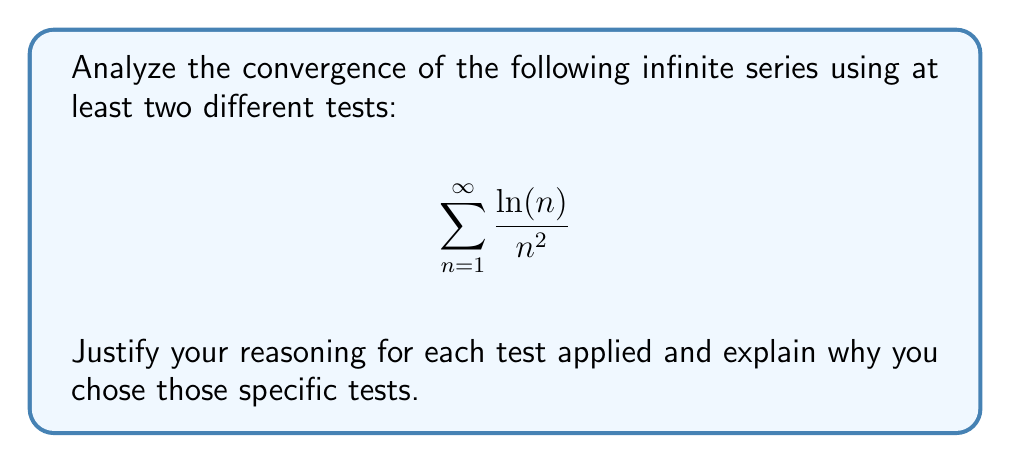Solve this math problem. Let's analyze the convergence of this series using multiple tests:

1. Comparison Test:

We can compare this series to a known convergent p-series. For $n \geq 3$, we have:

$$\frac{\ln(n)}{n^2} < \frac{n}{n^2} = \frac{1}{n}$$

Since $\sum_{n=1}^{\infty} \frac{1}{n}$ diverges (harmonic series), this comparison is not helpful. Let's try a tighter bound:

For $n \geq 3$, $\ln(n) < \sqrt{n}$. Therefore:

$$\frac{\ln(n)}{n^2} < \frac{\sqrt{n}}{n^2} = \frac{1}{n^{3/2}}$$

We know that $\sum_{n=1}^{\infty} \frac{1}{n^{3/2}}$ converges (p-series with $p > 1$). By the comparison test, our original series also converges.

2. Limit Comparison Test:

Let's compare our series to $\sum_{n=1}^{\infty} \frac{1}{n^{3/2}}$:

$$\lim_{n \to \infty} \frac{\frac{\ln(n)}{n^2}}{\frac{1}{n^{3/2}}} = \lim_{n \to \infty} \frac{\ln(n)}{n^{1/2}} = 0$$

Since this limit exists and is finite, both series have the same convergence behavior. As we know $\sum_{n=1}^{\infty} \frac{1}{n^{3/2}}$ converges, our original series also converges.

3. Ratio Test:

Let $a_n = \frac{\ln(n)}{n^2}$. Then:

$$\begin{align*}
\lim_{n \to \infty} \left|\frac{a_{n+1}}{a_n}\right| &= \lim_{n \to \infty} \left|\frac{\ln(n+1)}{(n+1)^2} \cdot \frac{n^2}{\ln(n)}\right| \\
&= \lim_{n \to \infty} \left(\frac{n}{n+1}\right)^2 \cdot \frac{\ln(n+1)}{\ln(n)} \\
&= 1 \cdot 1 = 1
\end{align*}$$

Since the limit equals 1, the ratio test is inconclusive.

We chose these tests because:
1. The comparison test is often useful for series involving logarithms and powers.
2. The limit comparison test can be more precise when direct comparison is difficult.
3. The ratio test is generally applicable and can sometimes provide conclusive results quickly.
Answer: The series $\sum_{n=1}^{\infty} \frac{\ln(n)}{n^2}$ converges. This is proven by both the comparison test and the limit comparison test, while the ratio test is inconclusive for this series. 